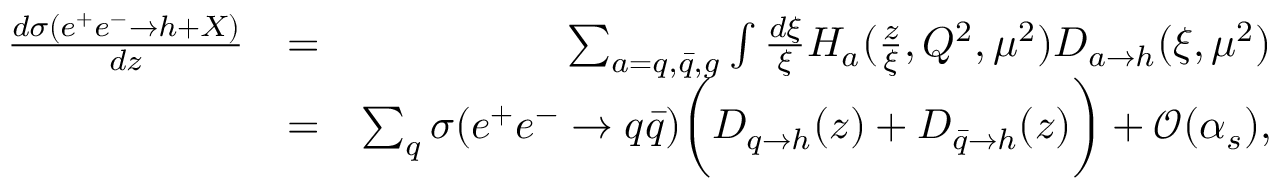<formula> <loc_0><loc_0><loc_500><loc_500>\begin{array} { r l r } { \frac { d \sigma ( e ^ { + } e ^ { - } \rightarrow h + X ) } { d z } } & { = } & { \sum _ { a = q , \bar { q } , g } \int \frac { d \xi } { \xi } H _ { a } ( \frac { z } { \xi } , Q ^ { 2 } , \mu ^ { 2 } ) D _ { a \rightarrow h } ( \xi , \mu ^ { 2 } ) } \\ & { = } & { \sum _ { q } \sigma ( e ^ { + } e ^ { - } \rightarrow q \bar { q } ) \left ( D _ { q \rightarrow h } ( z ) + D _ { \bar { q } \rightarrow h } ( z ) \right ) + { \mathcal { O } } ( \alpha _ { s } ) , } \end{array}</formula> 